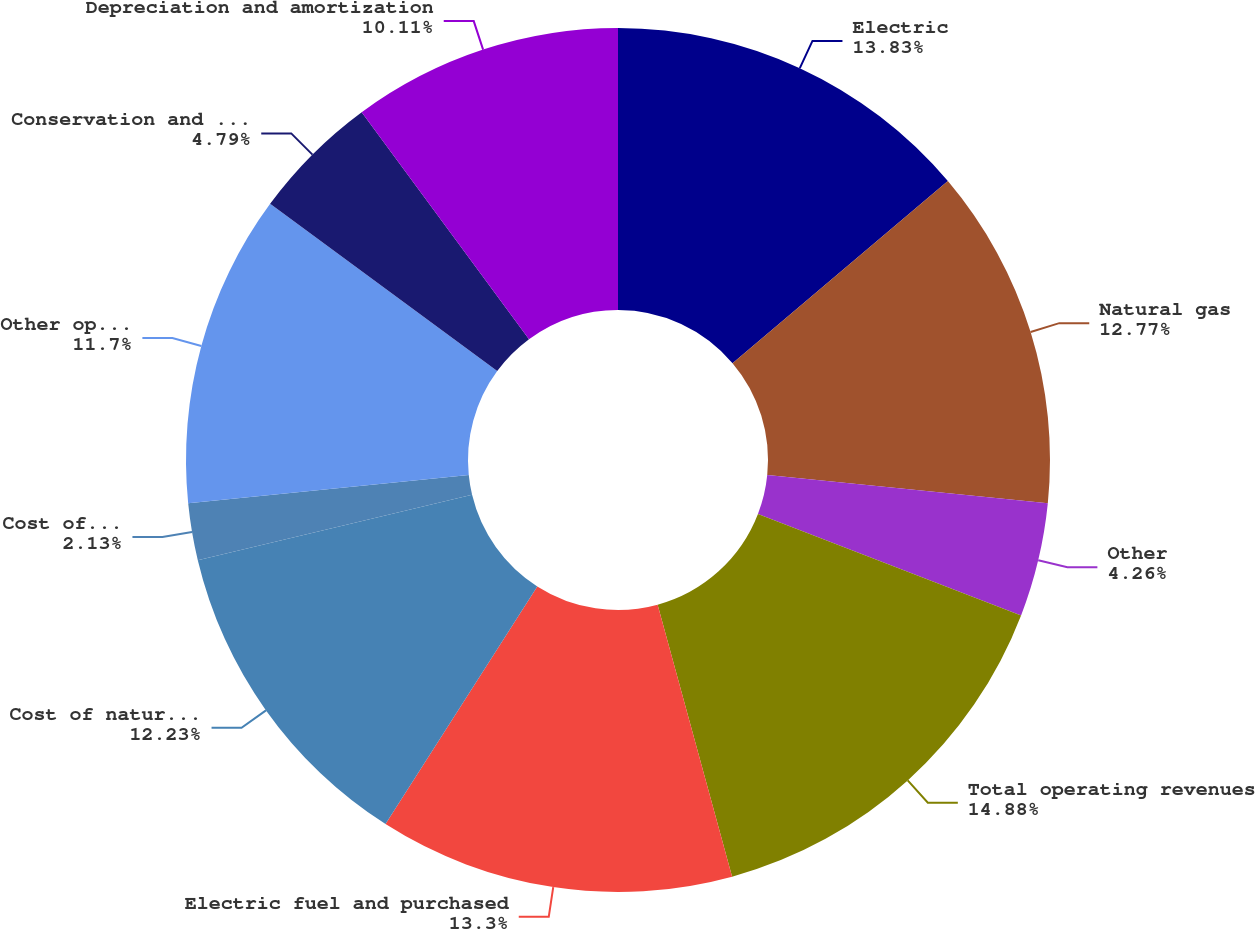<chart> <loc_0><loc_0><loc_500><loc_500><pie_chart><fcel>Electric<fcel>Natural gas<fcel>Other<fcel>Total operating revenues<fcel>Electric fuel and purchased<fcel>Cost of natural gas sold and<fcel>Cost of sales - other<fcel>Other operating and<fcel>Conservation and demand-side<fcel>Depreciation and amortization<nl><fcel>13.83%<fcel>12.77%<fcel>4.26%<fcel>14.89%<fcel>13.3%<fcel>12.23%<fcel>2.13%<fcel>11.7%<fcel>4.79%<fcel>10.11%<nl></chart> 